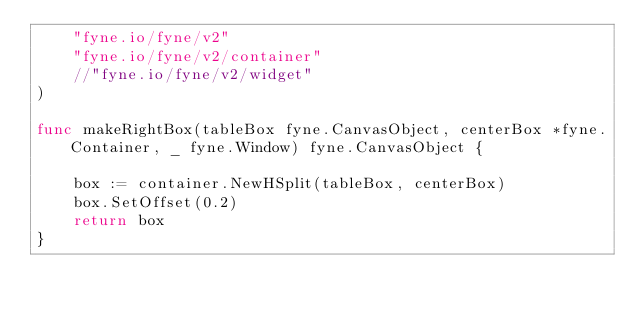Convert code to text. <code><loc_0><loc_0><loc_500><loc_500><_Go_>    "fyne.io/fyne/v2"
    "fyne.io/fyne/v2/container"
    //"fyne.io/fyne/v2/widget"
)

func makeRightBox(tableBox fyne.CanvasObject, centerBox *fyne.Container, _ fyne.Window) fyne.CanvasObject {

    box := container.NewHSplit(tableBox, centerBox)
    box.SetOffset(0.2)
    return box
}

</code> 